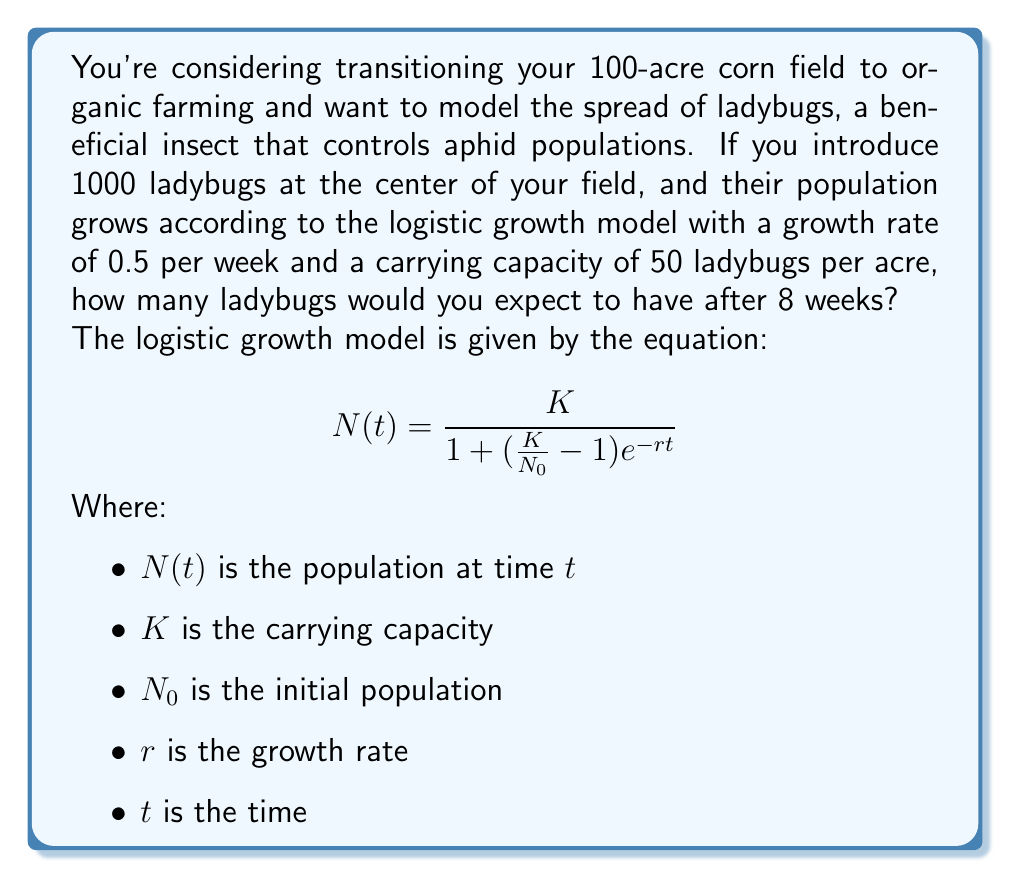Can you solve this math problem? Let's approach this step-by-step:

1) First, let's identify our variables:
   $K = 50 \times 100 = 5000$ (50 ladybugs per acre × 100 acres)
   $N_0 = 1000$ (initial population)
   $r = 0.5$ per week
   $t = 8$ weeks

2) Now, let's plug these values into our logistic growth equation:

   $$N(8) = \frac{5000}{1 + (\frac{5000}{1000} - 1)e^{-0.5 \times 8}}$$

3) Let's simplify the expression inside the parentheses:
   
   $$N(8) = \frac{5000}{1 + (5 - 1)e^{-4}}$$
   
   $$N(8) = \frac{5000}{1 + 4e^{-4}}$$

4) Now, let's calculate $e^{-4}$:
   
   $e^{-4} \approx 0.0183$

5) Plugging this back in:

   $$N(8) = \frac{5000}{1 + 4(0.0183)}$$
   
   $$N(8) = \frac{5000}{1 + 0.0732}$$
   
   $$N(8) = \frac{5000}{1.0732}$$

6) Finally, let's calculate this:

   $$N(8) \approx 4659.9$$

7) Since we're dealing with whole ladybugs, we'll round to the nearest integer.
Answer: After 8 weeks, you would expect to have approximately 4660 ladybugs in your field. 